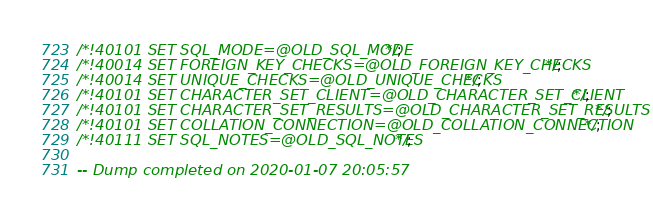Convert code to text. <code><loc_0><loc_0><loc_500><loc_500><_SQL_>
/*!40101 SET SQL_MODE=@OLD_SQL_MODE */;
/*!40014 SET FOREIGN_KEY_CHECKS=@OLD_FOREIGN_KEY_CHECKS */;
/*!40014 SET UNIQUE_CHECKS=@OLD_UNIQUE_CHECKS */;
/*!40101 SET CHARACTER_SET_CLIENT=@OLD_CHARACTER_SET_CLIENT */;
/*!40101 SET CHARACTER_SET_RESULTS=@OLD_CHARACTER_SET_RESULTS */;
/*!40101 SET COLLATION_CONNECTION=@OLD_COLLATION_CONNECTION */;
/*!40111 SET SQL_NOTES=@OLD_SQL_NOTES */;

-- Dump completed on 2020-01-07 20:05:57
</code> 